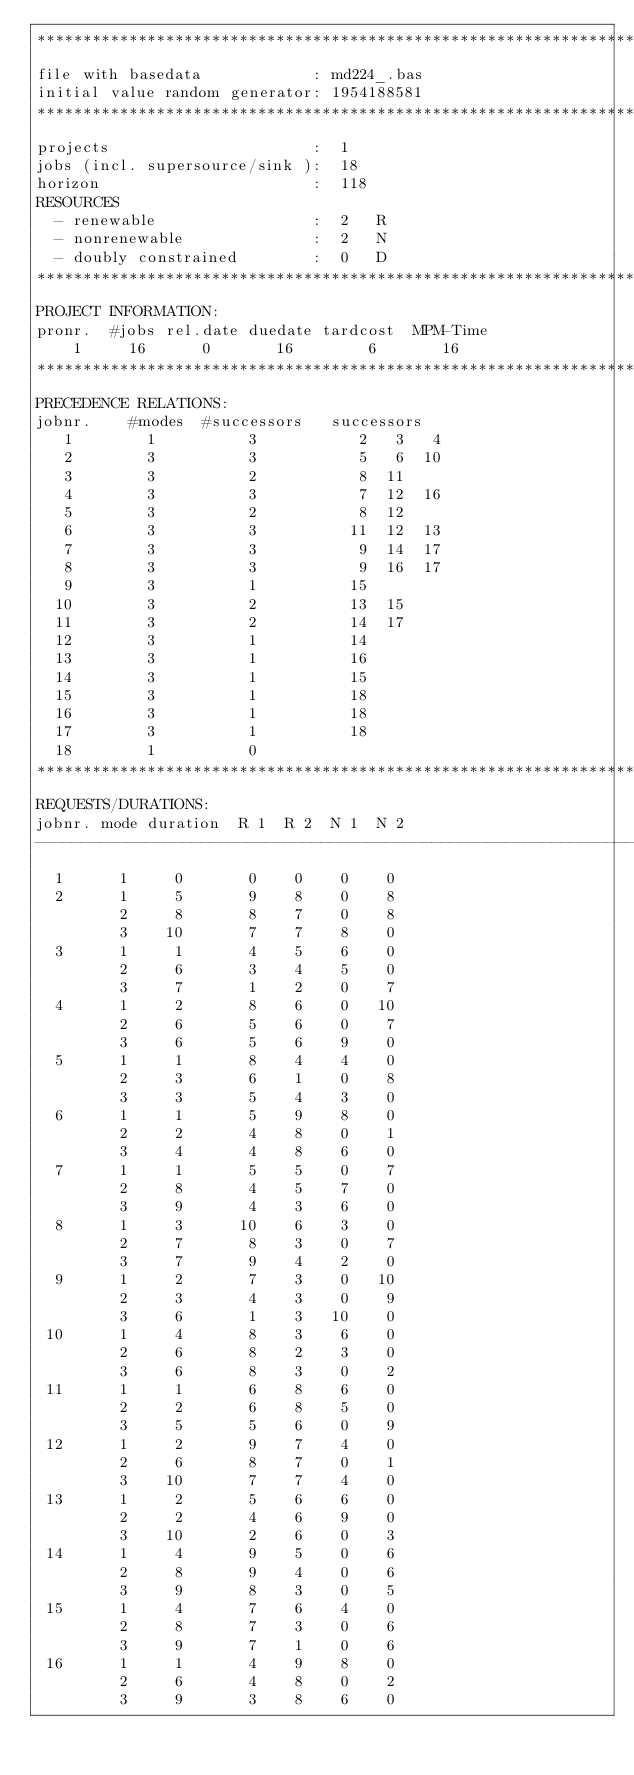Convert code to text. <code><loc_0><loc_0><loc_500><loc_500><_ObjectiveC_>************************************************************************
file with basedata            : md224_.bas
initial value random generator: 1954188581
************************************************************************
projects                      :  1
jobs (incl. supersource/sink ):  18
horizon                       :  118
RESOURCES
  - renewable                 :  2   R
  - nonrenewable              :  2   N
  - doubly constrained        :  0   D
************************************************************************
PROJECT INFORMATION:
pronr.  #jobs rel.date duedate tardcost  MPM-Time
    1     16      0       16        6       16
************************************************************************
PRECEDENCE RELATIONS:
jobnr.    #modes  #successors   successors
   1        1          3           2   3   4
   2        3          3           5   6  10
   3        3          2           8  11
   4        3          3           7  12  16
   5        3          2           8  12
   6        3          3          11  12  13
   7        3          3           9  14  17
   8        3          3           9  16  17
   9        3          1          15
  10        3          2          13  15
  11        3          2          14  17
  12        3          1          14
  13        3          1          16
  14        3          1          15
  15        3          1          18
  16        3          1          18
  17        3          1          18
  18        1          0        
************************************************************************
REQUESTS/DURATIONS:
jobnr. mode duration  R 1  R 2  N 1  N 2
------------------------------------------------------------------------
  1      1     0       0    0    0    0
  2      1     5       9    8    0    8
         2     8       8    7    0    8
         3    10       7    7    8    0
  3      1     1       4    5    6    0
         2     6       3    4    5    0
         3     7       1    2    0    7
  4      1     2       8    6    0   10
         2     6       5    6    0    7
         3     6       5    6    9    0
  5      1     1       8    4    4    0
         2     3       6    1    0    8
         3     3       5    4    3    0
  6      1     1       5    9    8    0
         2     2       4    8    0    1
         3     4       4    8    6    0
  7      1     1       5    5    0    7
         2     8       4    5    7    0
         3     9       4    3    6    0
  8      1     3      10    6    3    0
         2     7       8    3    0    7
         3     7       9    4    2    0
  9      1     2       7    3    0   10
         2     3       4    3    0    9
         3     6       1    3   10    0
 10      1     4       8    3    6    0
         2     6       8    2    3    0
         3     6       8    3    0    2
 11      1     1       6    8    6    0
         2     2       6    8    5    0
         3     5       5    6    0    9
 12      1     2       9    7    4    0
         2     6       8    7    0    1
         3    10       7    7    4    0
 13      1     2       5    6    6    0
         2     2       4    6    9    0
         3    10       2    6    0    3
 14      1     4       9    5    0    6
         2     8       9    4    0    6
         3     9       8    3    0    5
 15      1     4       7    6    4    0
         2     8       7    3    0    6
         3     9       7    1    0    6
 16      1     1       4    9    8    0
         2     6       4    8    0    2
         3     9       3    8    6    0</code> 